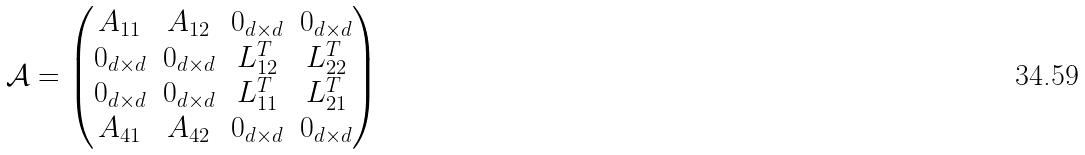Convert formula to latex. <formula><loc_0><loc_0><loc_500><loc_500>\mathcal { A } = \begin{pmatrix} A _ { 1 1 } & A _ { 1 2 } & 0 _ { d \times d } & 0 _ { d \times d } \\ 0 _ { d \times d } & 0 _ { d \times d } & L _ { 1 2 } ^ { T } & L _ { 2 2 } ^ { T } \\ 0 _ { d \times d } & 0 _ { d \times d } & L _ { 1 1 } ^ { T } & L _ { 2 1 } ^ { T } \\ A _ { 4 1 } & A _ { 4 2 } & 0 _ { d \times d } & 0 _ { d \times d } \end{pmatrix}</formula> 